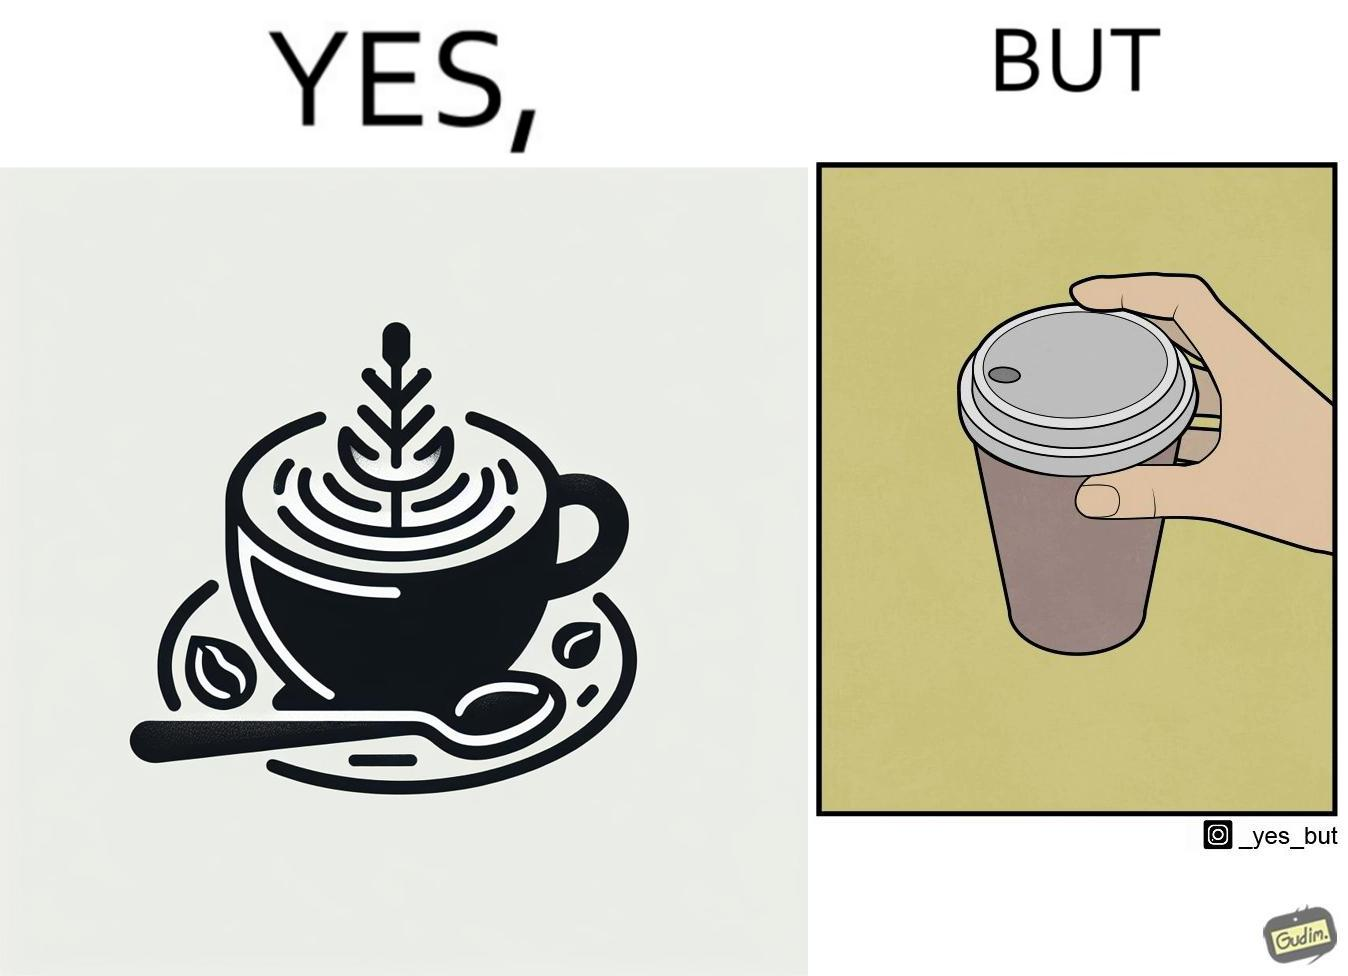What is shown in this image? The images are funny since it shows how someone has put effort into a cup of coffee to do latte art on it only for it to be invisible after a lid is put on the coffee cup before serving to a customer 